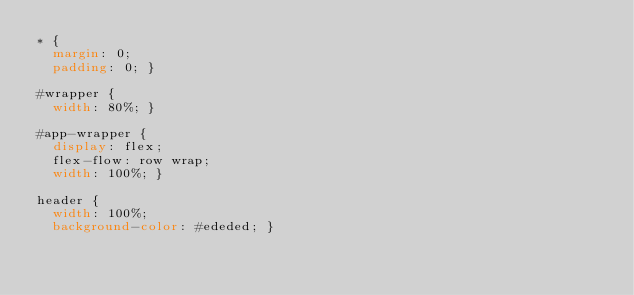<code> <loc_0><loc_0><loc_500><loc_500><_CSS_>* {
  margin: 0;
  padding: 0; }

#wrapper {
  width: 80%; }

#app-wrapper {
  display: flex;
  flex-flow: row wrap;
  width: 100%; }

header {
  width: 100%;
  background-color: #ededed; }
</code> 